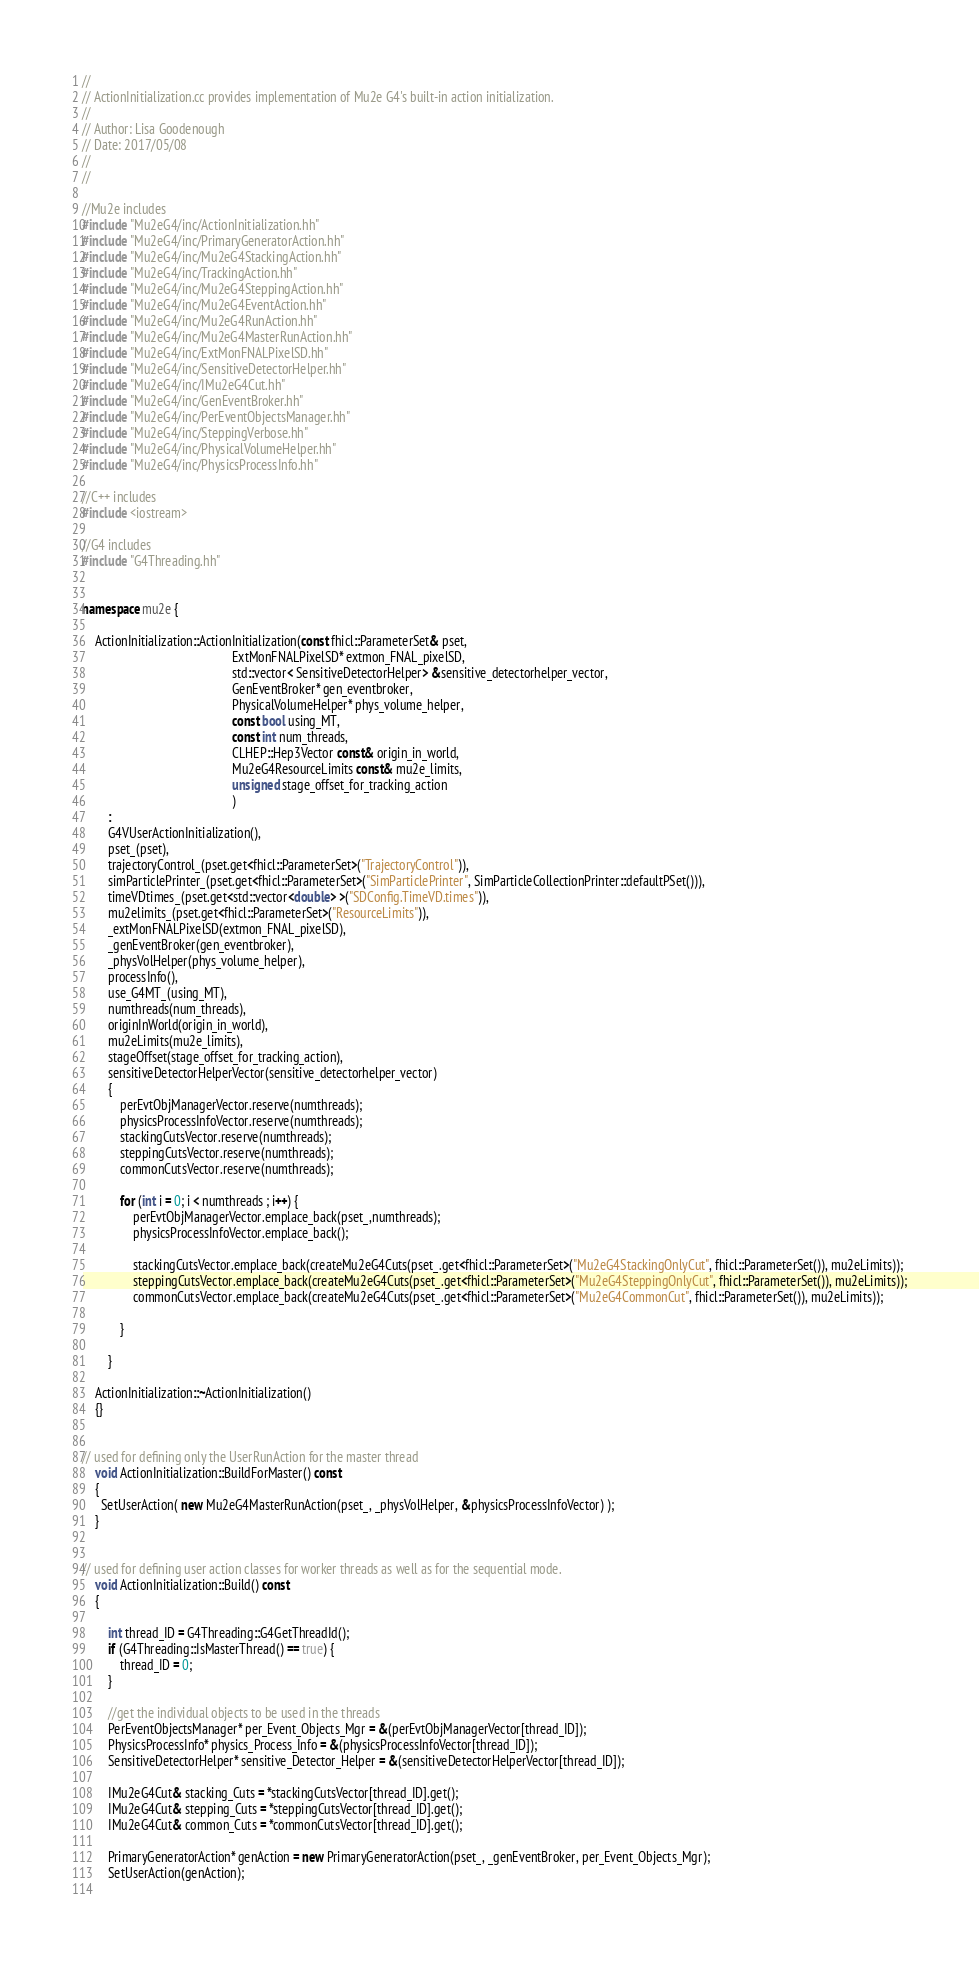<code> <loc_0><loc_0><loc_500><loc_500><_C++_>//
// ActionInitialization.cc provides implementation of Mu2e G4's built-in action initialization.
//
// Author: Lisa Goodenough
// Date: 2017/05/08
//
//

//Mu2e includes
#include "Mu2eG4/inc/ActionInitialization.hh"
#include "Mu2eG4/inc/PrimaryGeneratorAction.hh"
#include "Mu2eG4/inc/Mu2eG4StackingAction.hh"
#include "Mu2eG4/inc/TrackingAction.hh"
#include "Mu2eG4/inc/Mu2eG4SteppingAction.hh"
#include "Mu2eG4/inc/Mu2eG4EventAction.hh"
#include "Mu2eG4/inc/Mu2eG4RunAction.hh"
#include "Mu2eG4/inc/Mu2eG4MasterRunAction.hh"
#include "Mu2eG4/inc/ExtMonFNALPixelSD.hh"
#include "Mu2eG4/inc/SensitiveDetectorHelper.hh"
#include "Mu2eG4/inc/IMu2eG4Cut.hh"
#include "Mu2eG4/inc/GenEventBroker.hh"
#include "Mu2eG4/inc/PerEventObjectsManager.hh"
#include "Mu2eG4/inc/SteppingVerbose.hh"
#include "Mu2eG4/inc/PhysicalVolumeHelper.hh"
#include "Mu2eG4/inc/PhysicsProcessInfo.hh"

//C++ includes
#include <iostream>

//G4 includes
#include "G4Threading.hh"


namespace mu2e {
    
    ActionInitialization::ActionInitialization(const fhicl::ParameterSet& pset,
                                               ExtMonFNALPixelSD* extmon_FNAL_pixelSD,
                                               std::vector< SensitiveDetectorHelper> &sensitive_detectorhelper_vector,
                                               GenEventBroker* gen_eventbroker,
                                               PhysicalVolumeHelper* phys_volume_helper,
                                               const bool using_MT,
                                               const int num_threads,
                                               CLHEP::Hep3Vector const& origin_in_world,
                                               Mu2eG4ResourceLimits const& mu2e_limits,
                                               unsigned stage_offset_for_tracking_action
                                               )
        :
        G4VUserActionInitialization(),
        pset_(pset),
        trajectoryControl_(pset.get<fhicl::ParameterSet>("TrajectoryControl")),
        simParticlePrinter_(pset.get<fhicl::ParameterSet>("SimParticlePrinter", SimParticleCollectionPrinter::defaultPSet())),
        timeVDtimes_(pset.get<std::vector<double> >("SDConfig.TimeVD.times")),
        mu2elimits_(pset.get<fhicl::ParameterSet>("ResourceLimits")),
        _extMonFNALPixelSD(extmon_FNAL_pixelSD),
        _genEventBroker(gen_eventbroker),
        _physVolHelper(phys_volume_helper),
        processInfo(),
        use_G4MT_(using_MT),
        numthreads(num_threads),
        originInWorld(origin_in_world),
        mu2eLimits(mu2e_limits),
        stageOffset(stage_offset_for_tracking_action),
        sensitiveDetectorHelperVector(sensitive_detectorhelper_vector)
        {
            perEvtObjManagerVector.reserve(numthreads);
            physicsProcessInfoVector.reserve(numthreads);
            stackingCutsVector.reserve(numthreads);
            steppingCutsVector.reserve(numthreads);
            commonCutsVector.reserve(numthreads);
            
            for (int i = 0; i < numthreads ; i++) {
                perEvtObjManagerVector.emplace_back(pset_,numthreads);
                physicsProcessInfoVector.emplace_back();
                
                stackingCutsVector.emplace_back(createMu2eG4Cuts(pset_.get<fhicl::ParameterSet>("Mu2eG4StackingOnlyCut", fhicl::ParameterSet()), mu2eLimits));
                steppingCutsVector.emplace_back(createMu2eG4Cuts(pset_.get<fhicl::ParameterSet>("Mu2eG4SteppingOnlyCut", fhicl::ParameterSet()), mu2eLimits));
                commonCutsVector.emplace_back(createMu2eG4Cuts(pset_.get<fhicl::ParameterSet>("Mu2eG4CommonCut", fhicl::ParameterSet()), mu2eLimits));
                
            }

        }
    
    ActionInitialization::~ActionInitialization()
    {}

    
// used for defining only the UserRunAction for the master thread
    void ActionInitialization::BuildForMaster() const
    {
      SetUserAction( new Mu2eG4MasterRunAction(pset_, _physVolHelper, &physicsProcessInfoVector) );
    }
    
    
// used for defining user action classes for worker threads as well as for the sequential mode.
    void ActionInitialization::Build() const
    {        
    
        int thread_ID = G4Threading::G4GetThreadId();
        if (G4Threading::IsMasterThread() == true) {
            thread_ID = 0;
        }
        
        //get the individual objects to be used in the threads
        PerEventObjectsManager* per_Event_Objects_Mgr = &(perEvtObjManagerVector[thread_ID]);
        PhysicsProcessInfo* physics_Process_Info = &(physicsProcessInfoVector[thread_ID]);
        SensitiveDetectorHelper* sensitive_Detector_Helper = &(sensitiveDetectorHelperVector[thread_ID]);
        
        IMu2eG4Cut& stacking_Cuts = *stackingCutsVector[thread_ID].get();
        IMu2eG4Cut& stepping_Cuts = *steppingCutsVector[thread_ID].get();
        IMu2eG4Cut& common_Cuts = *commonCutsVector[thread_ID].get();
        
        PrimaryGeneratorAction* genAction = new PrimaryGeneratorAction(pset_, _genEventBroker, per_Event_Objects_Mgr);
        SetUserAction(genAction);
    </code> 